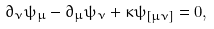Convert formula to latex. <formula><loc_0><loc_0><loc_500><loc_500>\partial _ { \nu } \psi _ { \mu } - \partial _ { \mu } \psi _ { \nu } + \kappa \psi _ { [ \mu \nu ] } = 0 ,</formula> 